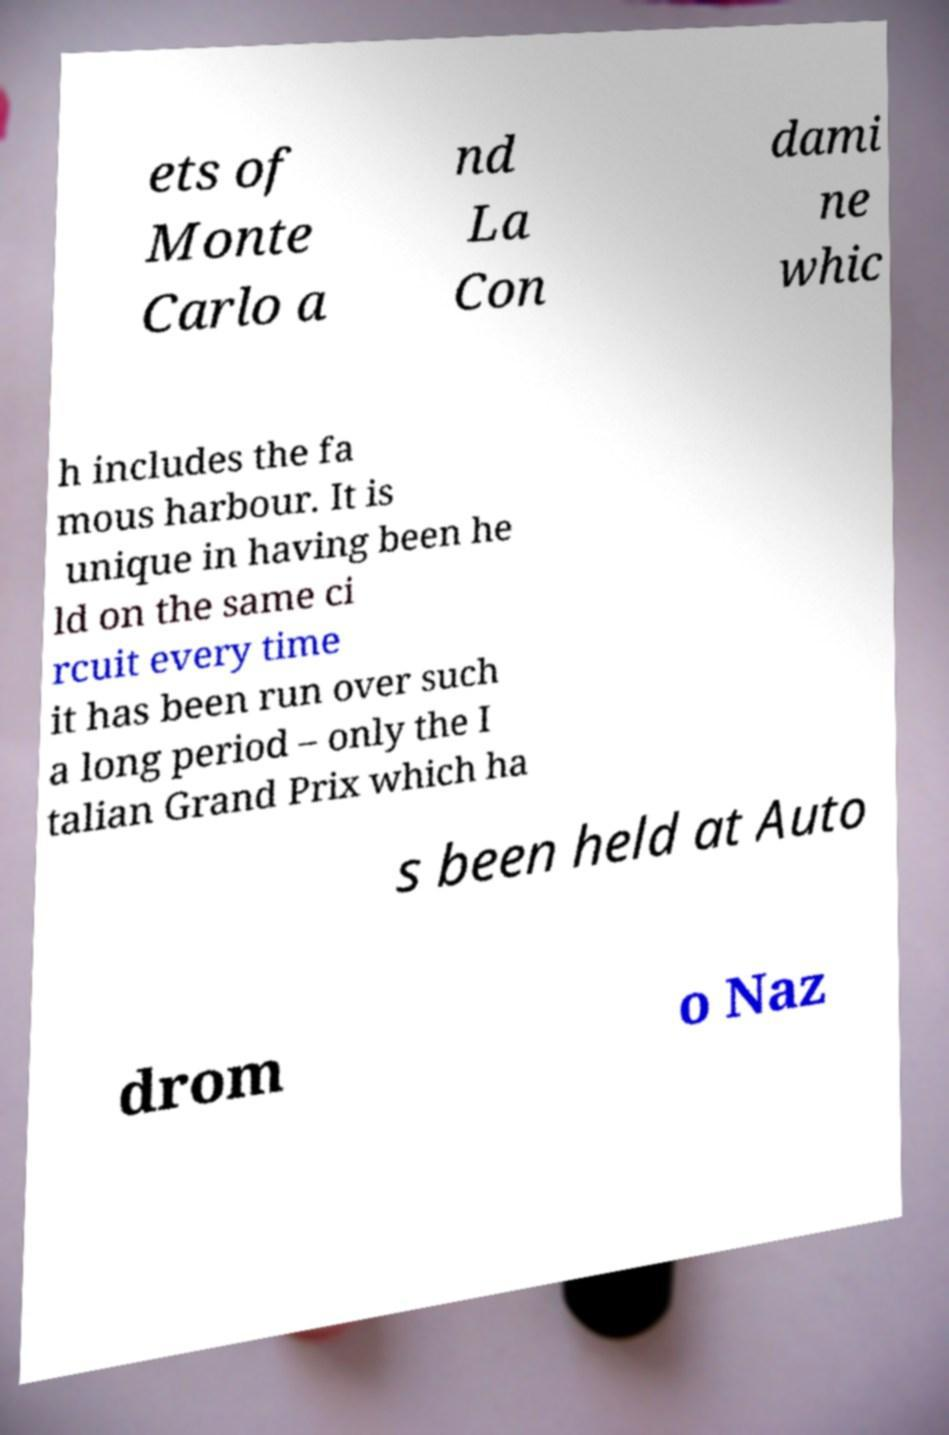For documentation purposes, I need the text within this image transcribed. Could you provide that? ets of Monte Carlo a nd La Con dami ne whic h includes the fa mous harbour. It is unique in having been he ld on the same ci rcuit every time it has been run over such a long period – only the I talian Grand Prix which ha s been held at Auto drom o Naz 